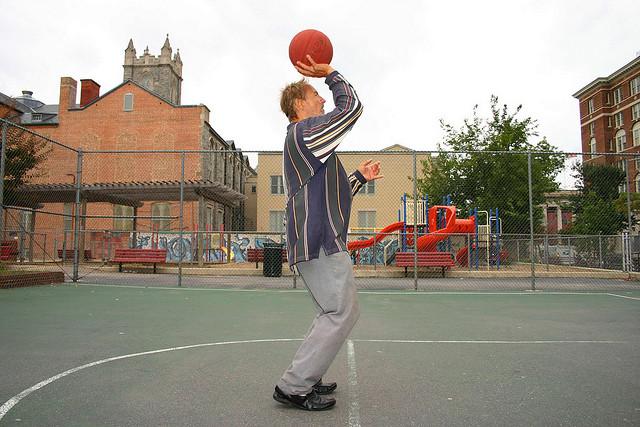Is he dressed to play basketball?
Keep it brief. No. What is he holding?
Give a very brief answer. Basketball. What is the person standing in a circle for?
Keep it brief. Free throw. 